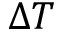Convert formula to latex. <formula><loc_0><loc_0><loc_500><loc_500>\Delta T</formula> 